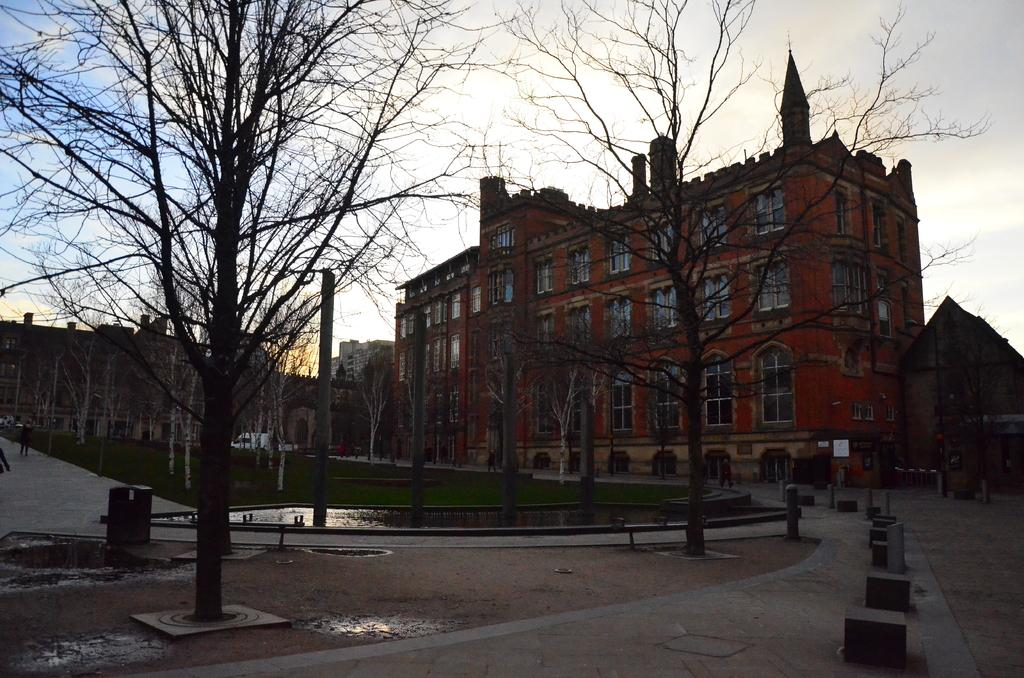What type of structures can be seen in the image? There are many buildings in the image. What type of barriers are present in the image? Walls are visible in the image. What type of windows are present in the buildings? Glass windows are present in the image. What type of vegetation can be seen in the image? Trees are visible in the image. What type of vertical structures are present in the image? Poles are present in the image. What type of surface can be seen in the image? Water is visible in the image. What type of paths are present in the image? Walkways are present in the image. What can be seen in the background of the image? The sky is visible in the background of the image. What type of ground cover can be seen in the image? Grass is visible in the image. How many fowl are present in the image? There are no fowl present in the image. Can you touch the territory in the image? The concept of "territory" is not applicable to the image, as it is a photograph and not a physical location. 